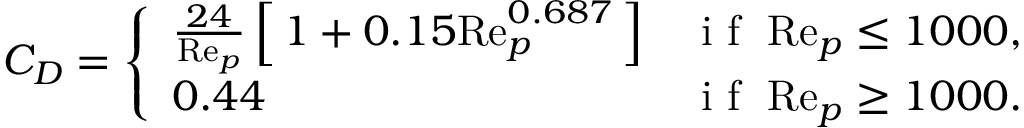<formula> <loc_0><loc_0><loc_500><loc_500>C _ { D } = \left \{ \begin{array} { l l } { \frac { 2 4 } { R e _ { p } } \left [ \, 1 + 0 . 1 5 R e _ { p } ^ { 0 . 6 8 7 } \, \right ] } & { i f \, R e _ { p } \leq 1 0 0 0 , } \\ { 0 . 4 4 } & { i f \, R e _ { p } \geq 1 0 0 0 . } \end{array}</formula> 